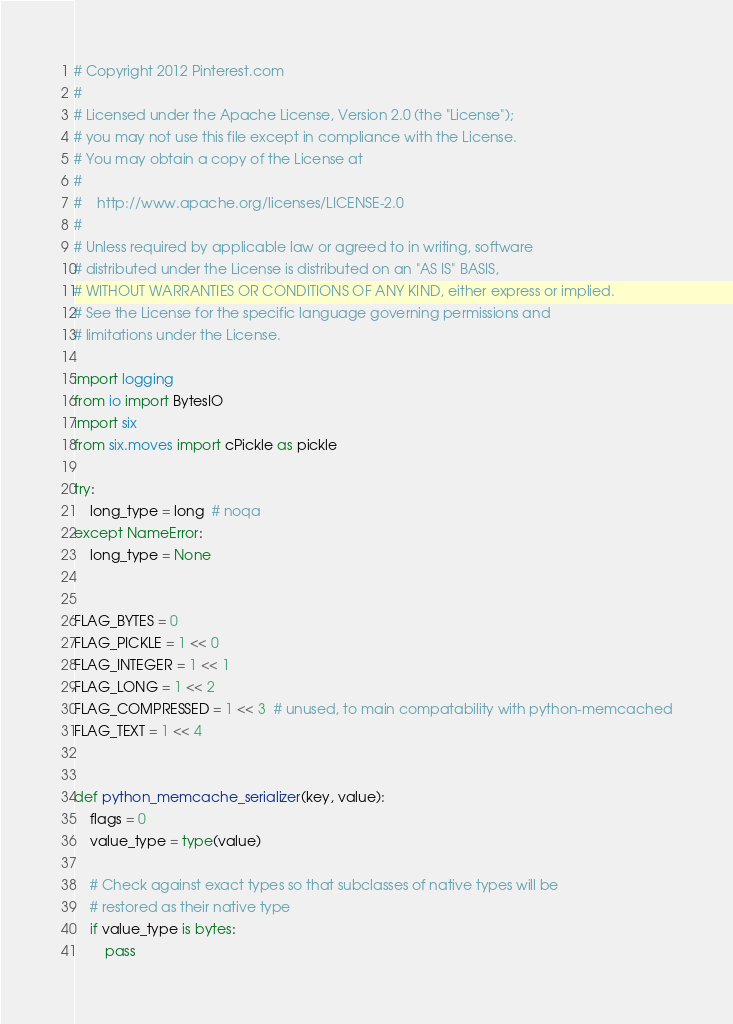Convert code to text. <code><loc_0><loc_0><loc_500><loc_500><_Python_># Copyright 2012 Pinterest.com
#
# Licensed under the Apache License, Version 2.0 (the "License");
# you may not use this file except in compliance with the License.
# You may obtain a copy of the License at
#
#    http://www.apache.org/licenses/LICENSE-2.0
#
# Unless required by applicable law or agreed to in writing, software
# distributed under the License is distributed on an "AS IS" BASIS,
# WITHOUT WARRANTIES OR CONDITIONS OF ANY KIND, either express or implied.
# See the License for the specific language governing permissions and
# limitations under the License.

import logging
from io import BytesIO
import six
from six.moves import cPickle as pickle

try:
    long_type = long  # noqa
except NameError:
    long_type = None


FLAG_BYTES = 0
FLAG_PICKLE = 1 << 0
FLAG_INTEGER = 1 << 1
FLAG_LONG = 1 << 2
FLAG_COMPRESSED = 1 << 3  # unused, to main compatability with python-memcached
FLAG_TEXT = 1 << 4


def python_memcache_serializer(key, value):
    flags = 0
    value_type = type(value)

    # Check against exact types so that subclasses of native types will be
    # restored as their native type
    if value_type is bytes:
        pass
</code> 